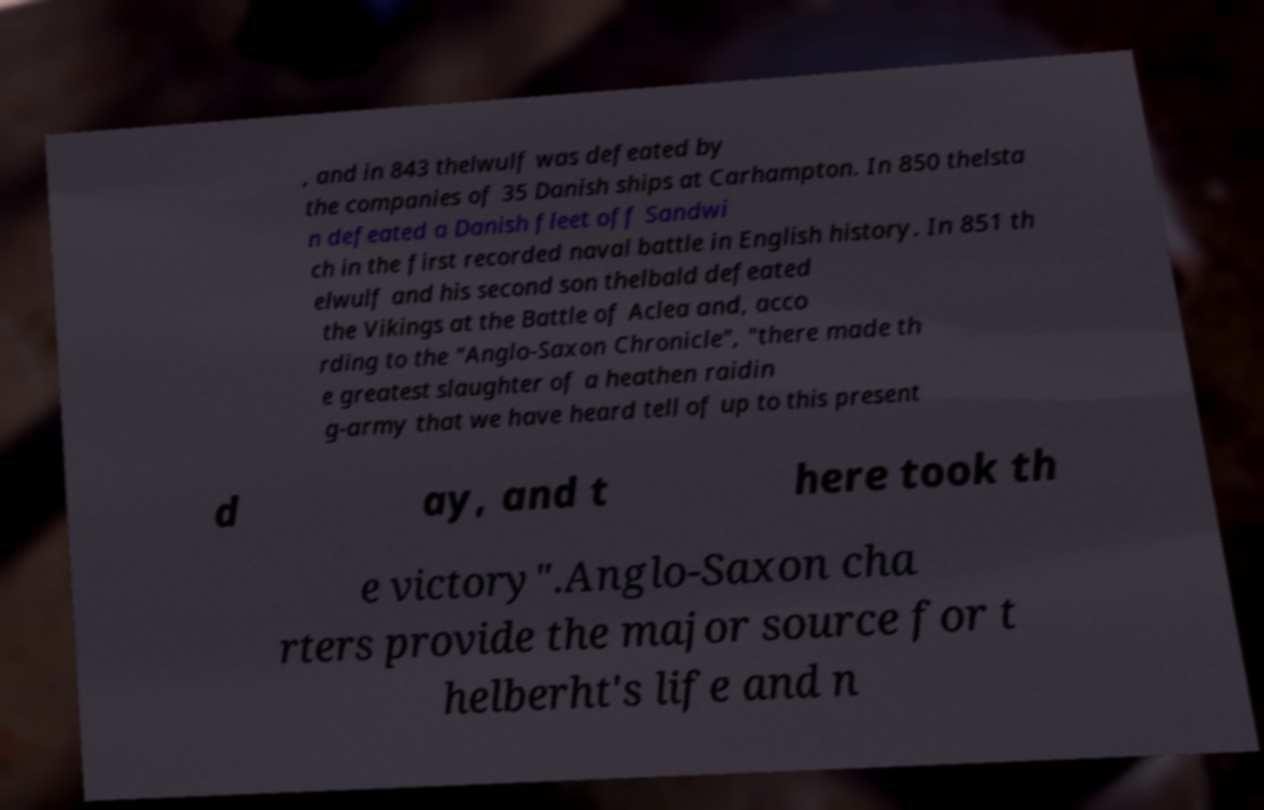What messages or text are displayed in this image? I need them in a readable, typed format. , and in 843 thelwulf was defeated by the companies of 35 Danish ships at Carhampton. In 850 thelsta n defeated a Danish fleet off Sandwi ch in the first recorded naval battle in English history. In 851 th elwulf and his second son thelbald defeated the Vikings at the Battle of Aclea and, acco rding to the "Anglo-Saxon Chronicle", "there made th e greatest slaughter of a heathen raidin g-army that we have heard tell of up to this present d ay, and t here took th e victory".Anglo-Saxon cha rters provide the major source for t helberht's life and n 